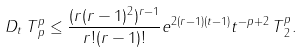Convert formula to latex. <formula><loc_0><loc_0><loc_500><loc_500>\| D _ { t } \, T \| _ { p } ^ { p } \leq \frac { ( r ( r - 1 ) ^ { 2 } ) ^ { r - 1 } } { r ! ( r - 1 ) ! } e ^ { 2 ( r - 1 ) ( t - 1 ) } t ^ { - p + 2 } \, \| T \| _ { 2 } ^ { p } .</formula> 